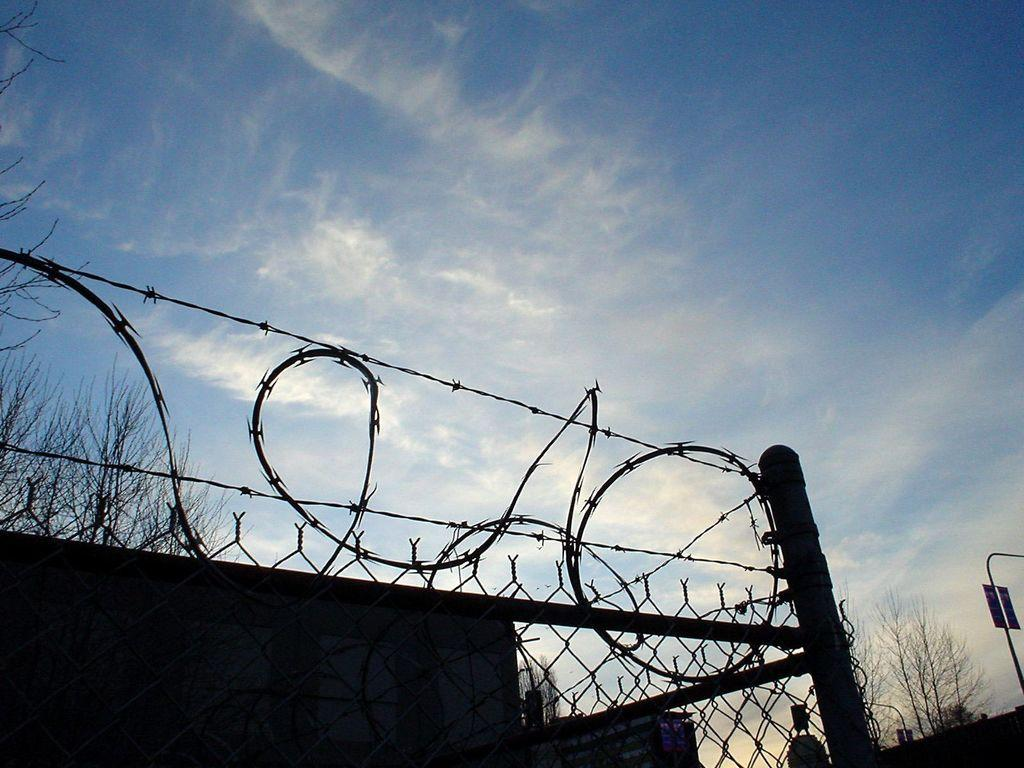What type of barrier is present in the image? There is a metal fence in the image. What type of natural elements can be seen in the image? There are trees in the image. What type of man-made structure is visible in the image? There appears to be a building in the image. How would you describe the sky in the image? The sky is blue and cloudy in the image. What is attached to a pole in the image? There is a board attached to a pole in the image. How many snails can be seen crawling on the metal fence in the image? There are no snails present in the image; it only features a metal fence, trees, a building, a blue and cloudy sky, and a board attached to a pole. Is there a lake visible in the image? No, there is no lake present in the image. 